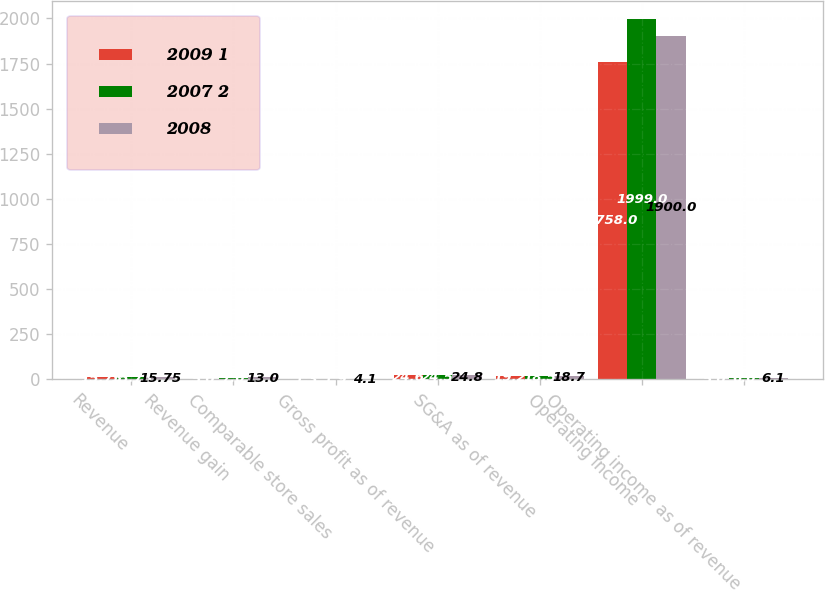Convert chart to OTSL. <chart><loc_0><loc_0><loc_500><loc_500><stacked_bar_chart><ecel><fcel>Revenue<fcel>Revenue gain<fcel>Comparable store sales<fcel>Gross profit as of revenue<fcel>SG&A as of revenue<fcel>Operating income<fcel>Operating income as of revenue<nl><fcel>2009 1<fcel>15.75<fcel>5<fcel>1.3<fcel>24.6<fcel>19.2<fcel>1758<fcel>5<nl><fcel>2007 2<fcel>15.75<fcel>7<fcel>1.9<fcel>24.5<fcel>18.5<fcel>1999<fcel>6<nl><fcel>2008<fcel>15.75<fcel>13<fcel>4.1<fcel>24.8<fcel>18.7<fcel>1900<fcel>6.1<nl></chart> 